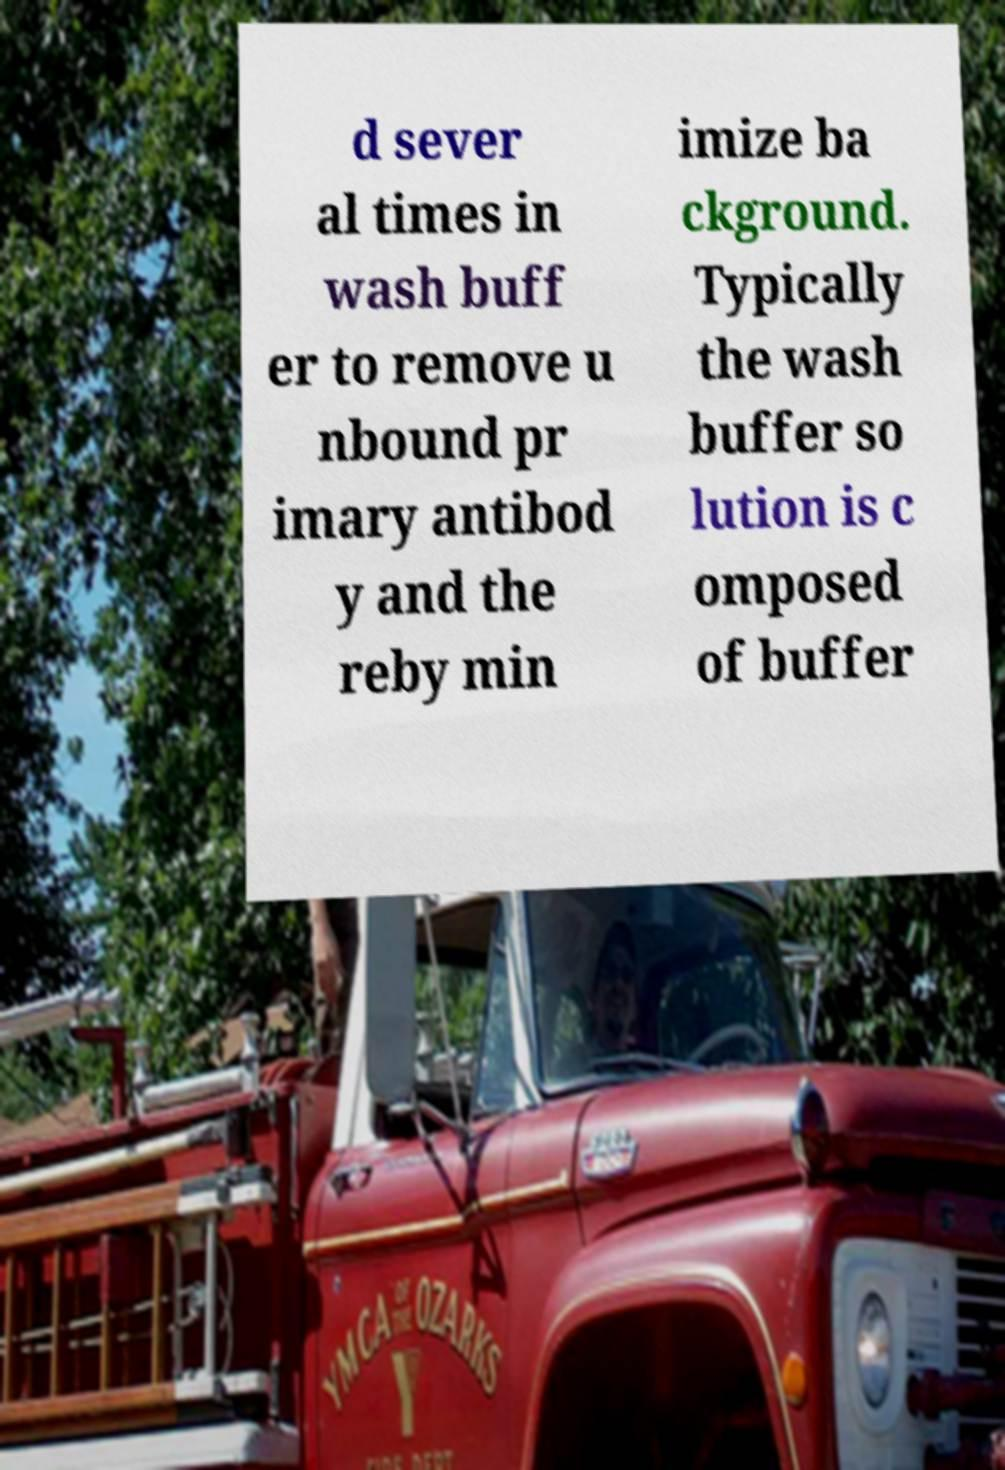Can you read and provide the text displayed in the image?This photo seems to have some interesting text. Can you extract and type it out for me? d sever al times in wash buff er to remove u nbound pr imary antibod y and the reby min imize ba ckground. Typically the wash buffer so lution is c omposed of buffer 